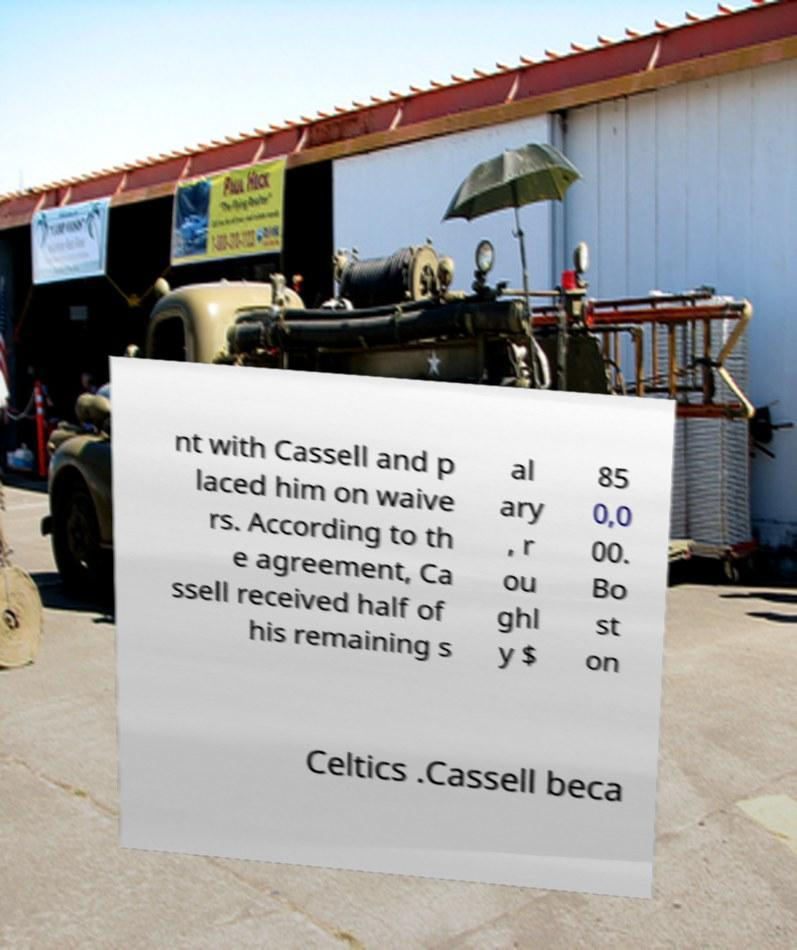Could you extract and type out the text from this image? nt with Cassell and p laced him on waive rs. According to th e agreement, Ca ssell received half of his remaining s al ary , r ou ghl y $ 85 0,0 00. Bo st on Celtics .Cassell beca 